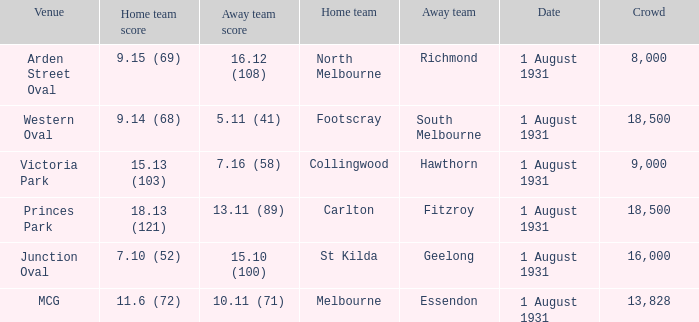What is the home teams score at Victoria Park? 15.13 (103). 